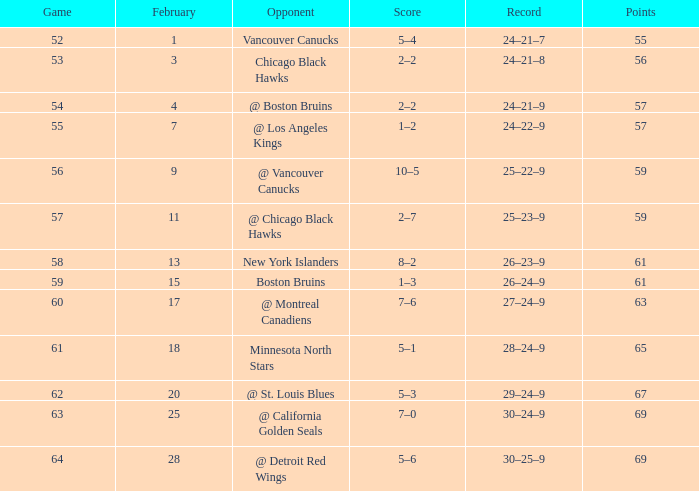Can you give me this table as a dict? {'header': ['Game', 'February', 'Opponent', 'Score', 'Record', 'Points'], 'rows': [['52', '1', 'Vancouver Canucks', '5–4', '24–21–7', '55'], ['53', '3', 'Chicago Black Hawks', '2–2', '24–21–8', '56'], ['54', '4', '@ Boston Bruins', '2–2', '24–21–9', '57'], ['55', '7', '@ Los Angeles Kings', '1–2', '24–22–9', '57'], ['56', '9', '@ Vancouver Canucks', '10–5', '25–22–9', '59'], ['57', '11', '@ Chicago Black Hawks', '2–7', '25–23–9', '59'], ['58', '13', 'New York Islanders', '8–2', '26–23–9', '61'], ['59', '15', 'Boston Bruins', '1–3', '26–24–9', '61'], ['60', '17', '@ Montreal Canadiens', '7–6', '27–24–9', '63'], ['61', '18', 'Minnesota North Stars', '5–1', '28–24–9', '65'], ['62', '20', '@ St. Louis Blues', '5–3', '29–24–9', '67'], ['63', '25', '@ California Golden Seals', '7–0', '30–24–9', '69'], ['64', '28', '@ Detroit Red Wings', '5–6', '30–25–9', '69']]} How many games have a record of 30–25–9 and more points than 69? 0.0. 